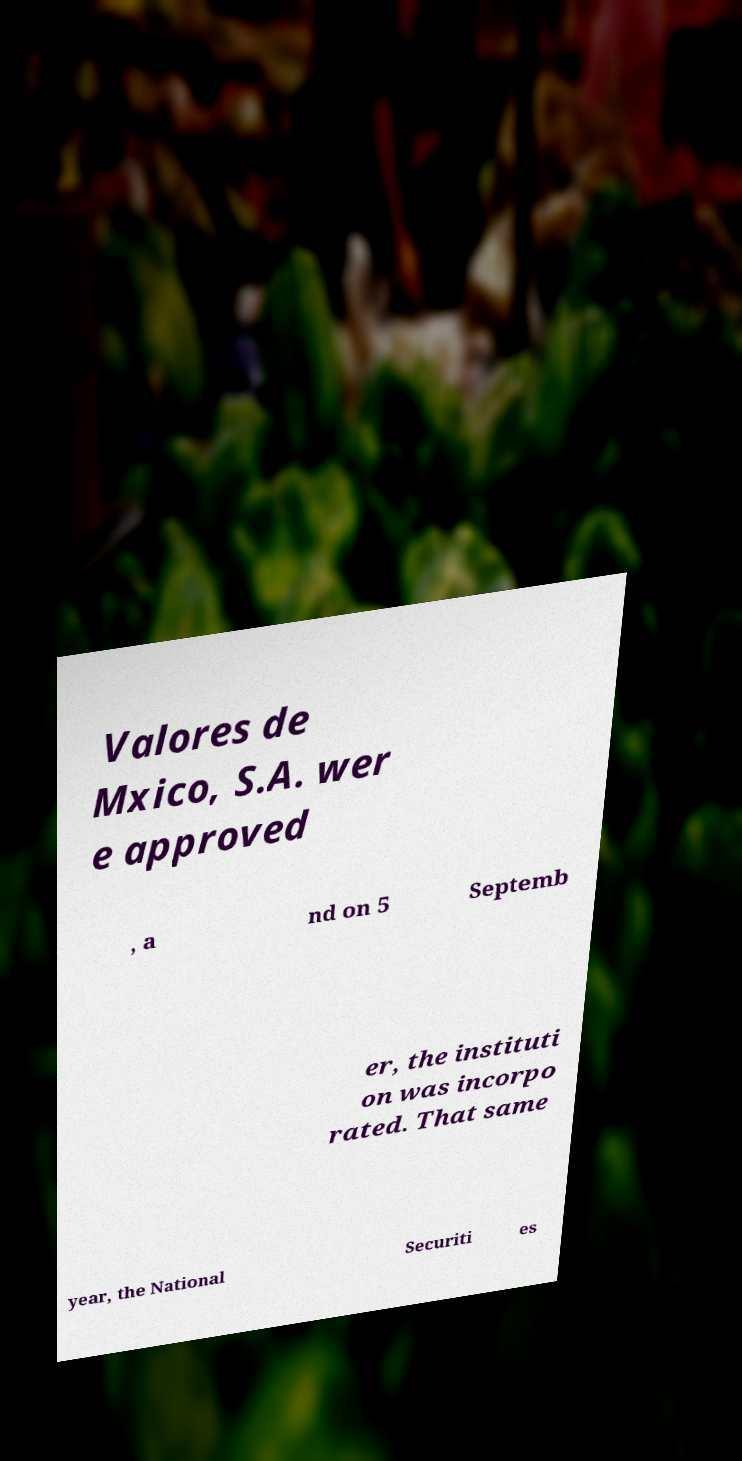Could you assist in decoding the text presented in this image and type it out clearly? Valores de Mxico, S.A. wer e approved , a nd on 5 Septemb er, the instituti on was incorpo rated. That same year, the National Securiti es 